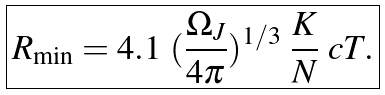Convert formula to latex. <formula><loc_0><loc_0><loc_500><loc_500>\boxed { R _ { \min } = 4 . 1 \ ( \frac { \Omega _ { J } } { 4 \pi } ) ^ { 1 / 3 } \ \frac { K } { N } \ c T . }</formula> 